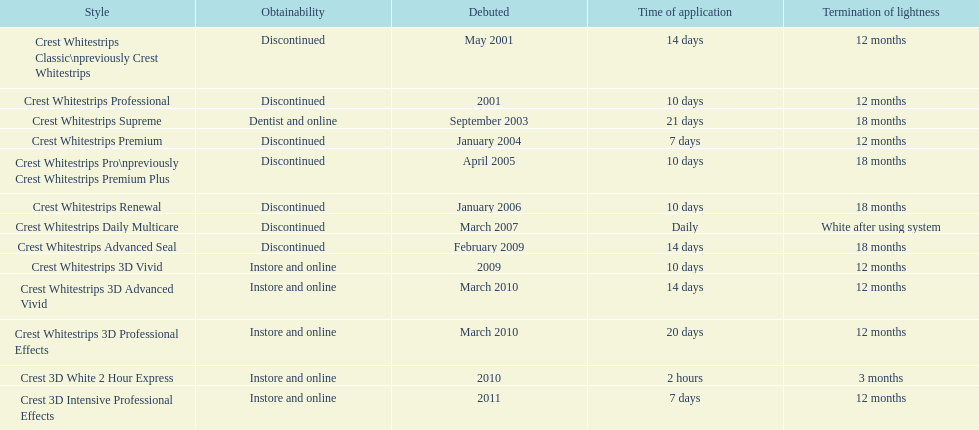Does the crest white strips pro last as long as the crest white strips renewal? Yes. 